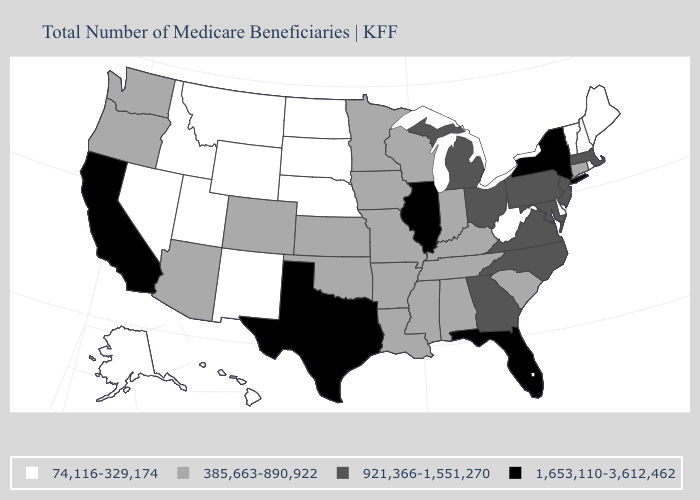Name the states that have a value in the range 385,663-890,922?
Keep it brief. Alabama, Arizona, Arkansas, Colorado, Connecticut, Indiana, Iowa, Kansas, Kentucky, Louisiana, Minnesota, Mississippi, Missouri, Oklahoma, Oregon, South Carolina, Tennessee, Washington, Wisconsin. Name the states that have a value in the range 921,366-1,551,270?
Give a very brief answer. Georgia, Maryland, Massachusetts, Michigan, New Jersey, North Carolina, Ohio, Pennsylvania, Virginia. Name the states that have a value in the range 74,116-329,174?
Write a very short answer. Alaska, Delaware, Hawaii, Idaho, Maine, Montana, Nebraska, Nevada, New Hampshire, New Mexico, North Dakota, Rhode Island, South Dakota, Utah, Vermont, West Virginia, Wyoming. Among the states that border Connecticut , which have the lowest value?
Answer briefly. Rhode Island. Which states have the lowest value in the USA?
Give a very brief answer. Alaska, Delaware, Hawaii, Idaho, Maine, Montana, Nebraska, Nevada, New Hampshire, New Mexico, North Dakota, Rhode Island, South Dakota, Utah, Vermont, West Virginia, Wyoming. Does Montana have a higher value than Kentucky?
Give a very brief answer. No. Which states have the lowest value in the USA?
Answer briefly. Alaska, Delaware, Hawaii, Idaho, Maine, Montana, Nebraska, Nevada, New Hampshire, New Mexico, North Dakota, Rhode Island, South Dakota, Utah, Vermont, West Virginia, Wyoming. Name the states that have a value in the range 385,663-890,922?
Answer briefly. Alabama, Arizona, Arkansas, Colorado, Connecticut, Indiana, Iowa, Kansas, Kentucky, Louisiana, Minnesota, Mississippi, Missouri, Oklahoma, Oregon, South Carolina, Tennessee, Washington, Wisconsin. What is the lowest value in the MidWest?
Quick response, please. 74,116-329,174. What is the lowest value in states that border Maine?
Concise answer only. 74,116-329,174. What is the highest value in states that border Idaho?
Be succinct. 385,663-890,922. Name the states that have a value in the range 1,653,110-3,612,462?
Concise answer only. California, Florida, Illinois, New York, Texas. Which states have the lowest value in the MidWest?
Keep it brief. Nebraska, North Dakota, South Dakota. What is the highest value in the MidWest ?
Write a very short answer. 1,653,110-3,612,462. What is the value of Pennsylvania?
Be succinct. 921,366-1,551,270. 